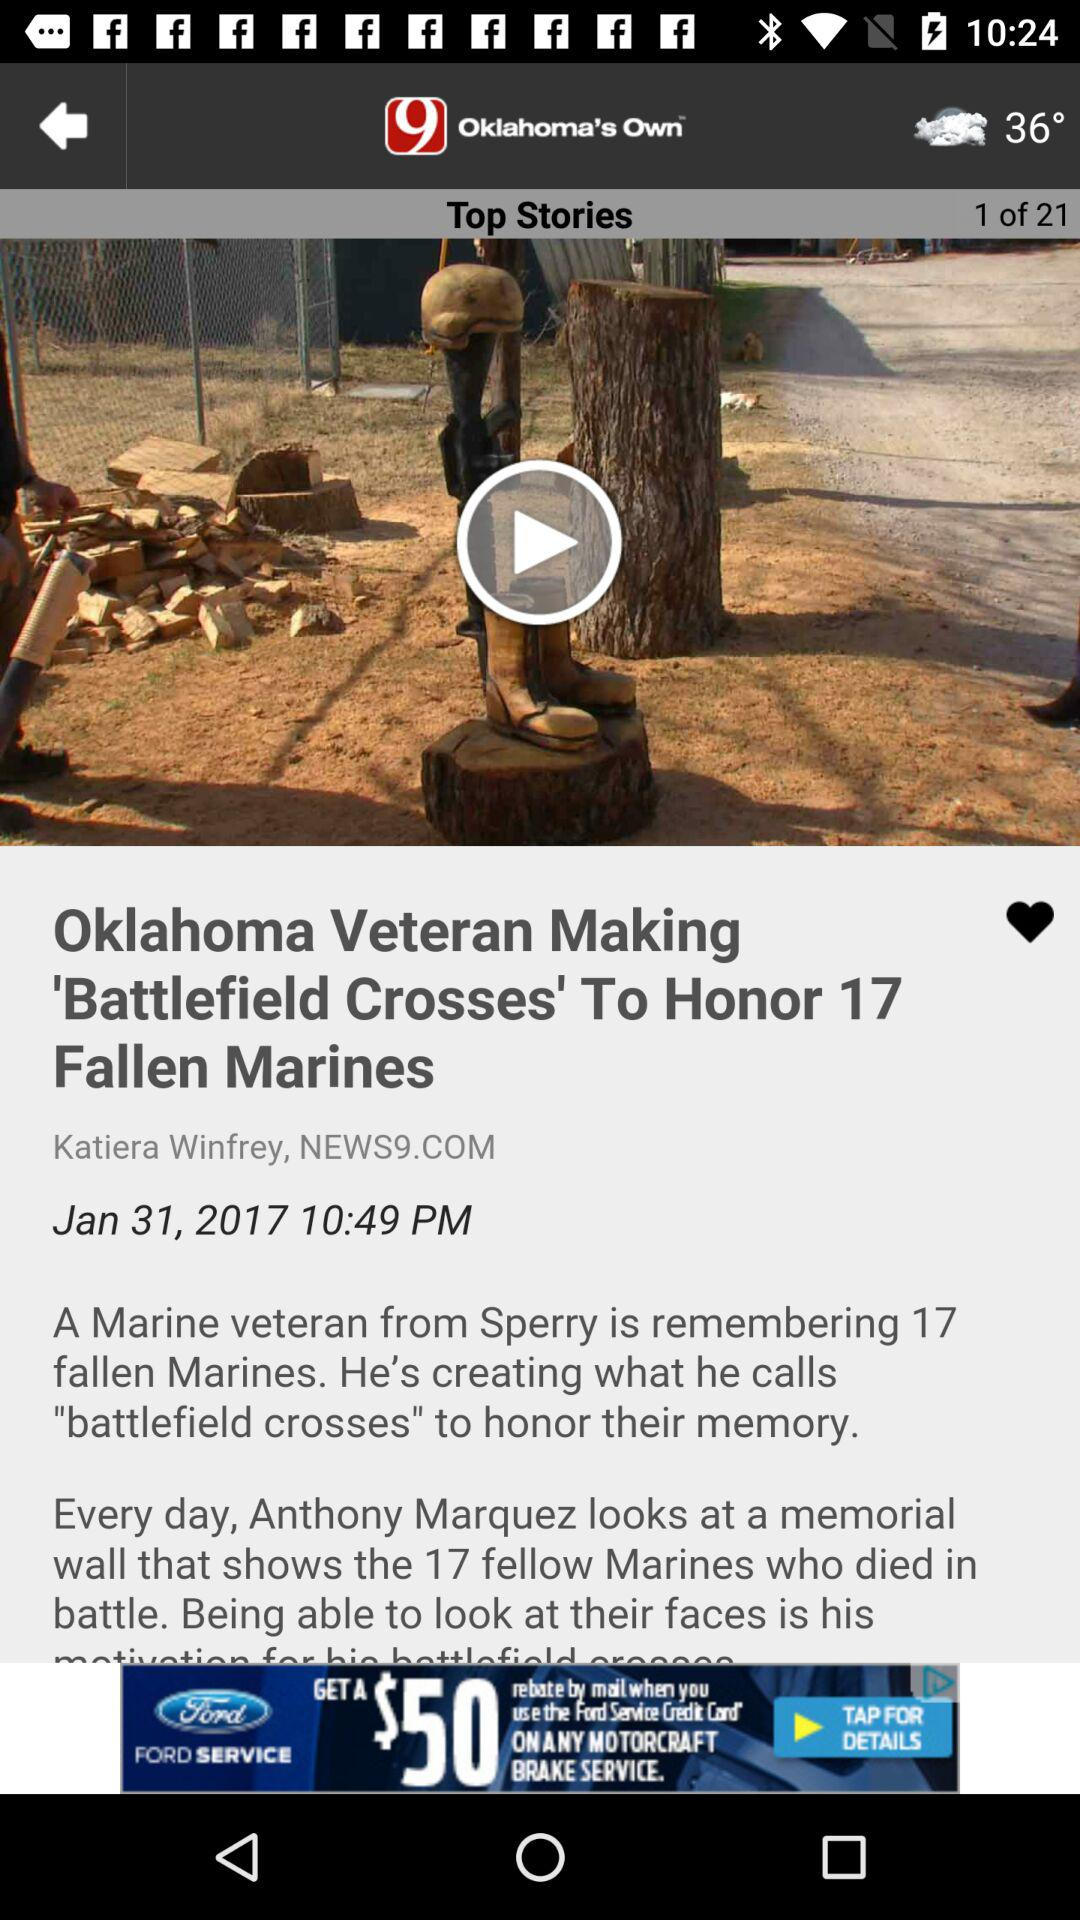What story am I on? You are on 1 story. 